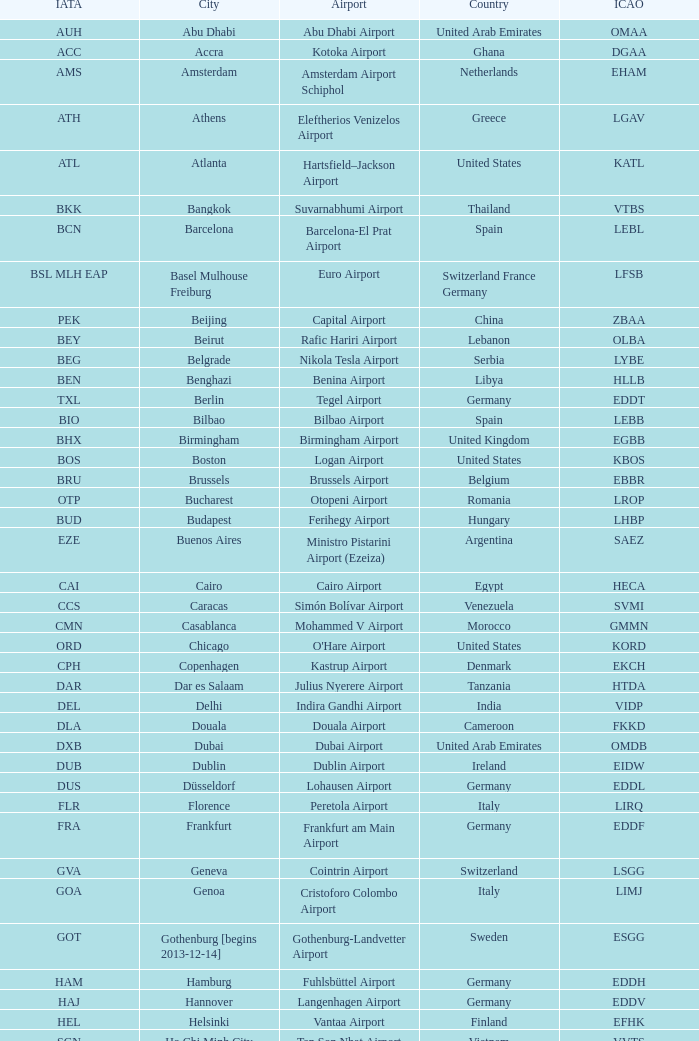Write the full table. {'header': ['IATA', 'City', 'Airport', 'Country', 'ICAO'], 'rows': [['AUH', 'Abu Dhabi', 'Abu Dhabi Airport', 'United Arab Emirates', 'OMAA'], ['ACC', 'Accra', 'Kotoka Airport', 'Ghana', 'DGAA'], ['AMS', 'Amsterdam', 'Amsterdam Airport Schiphol', 'Netherlands', 'EHAM'], ['ATH', 'Athens', 'Eleftherios Venizelos Airport', 'Greece', 'LGAV'], ['ATL', 'Atlanta', 'Hartsfield–Jackson Airport', 'United States', 'KATL'], ['BKK', 'Bangkok', 'Suvarnabhumi Airport', 'Thailand', 'VTBS'], ['BCN', 'Barcelona', 'Barcelona-El Prat Airport', 'Spain', 'LEBL'], ['BSL MLH EAP', 'Basel Mulhouse Freiburg', 'Euro Airport', 'Switzerland France Germany', 'LFSB'], ['PEK', 'Beijing', 'Capital Airport', 'China', 'ZBAA'], ['BEY', 'Beirut', 'Rafic Hariri Airport', 'Lebanon', 'OLBA'], ['BEG', 'Belgrade', 'Nikola Tesla Airport', 'Serbia', 'LYBE'], ['BEN', 'Benghazi', 'Benina Airport', 'Libya', 'HLLB'], ['TXL', 'Berlin', 'Tegel Airport', 'Germany', 'EDDT'], ['BIO', 'Bilbao', 'Bilbao Airport', 'Spain', 'LEBB'], ['BHX', 'Birmingham', 'Birmingham Airport', 'United Kingdom', 'EGBB'], ['BOS', 'Boston', 'Logan Airport', 'United States', 'KBOS'], ['BRU', 'Brussels', 'Brussels Airport', 'Belgium', 'EBBR'], ['OTP', 'Bucharest', 'Otopeni Airport', 'Romania', 'LROP'], ['BUD', 'Budapest', 'Ferihegy Airport', 'Hungary', 'LHBP'], ['EZE', 'Buenos Aires', 'Ministro Pistarini Airport (Ezeiza)', 'Argentina', 'SAEZ'], ['CAI', 'Cairo', 'Cairo Airport', 'Egypt', 'HECA'], ['CCS', 'Caracas', 'Simón Bolívar Airport', 'Venezuela', 'SVMI'], ['CMN', 'Casablanca', 'Mohammed V Airport', 'Morocco', 'GMMN'], ['ORD', 'Chicago', "O'Hare Airport", 'United States', 'KORD'], ['CPH', 'Copenhagen', 'Kastrup Airport', 'Denmark', 'EKCH'], ['DAR', 'Dar es Salaam', 'Julius Nyerere Airport', 'Tanzania', 'HTDA'], ['DEL', 'Delhi', 'Indira Gandhi Airport', 'India', 'VIDP'], ['DLA', 'Douala', 'Douala Airport', 'Cameroon', 'FKKD'], ['DXB', 'Dubai', 'Dubai Airport', 'United Arab Emirates', 'OMDB'], ['DUB', 'Dublin', 'Dublin Airport', 'Ireland', 'EIDW'], ['DUS', 'Düsseldorf', 'Lohausen Airport', 'Germany', 'EDDL'], ['FLR', 'Florence', 'Peretola Airport', 'Italy', 'LIRQ'], ['FRA', 'Frankfurt', 'Frankfurt am Main Airport', 'Germany', 'EDDF'], ['GVA', 'Geneva', 'Cointrin Airport', 'Switzerland', 'LSGG'], ['GOA', 'Genoa', 'Cristoforo Colombo Airport', 'Italy', 'LIMJ'], ['GOT', 'Gothenburg [begins 2013-12-14]', 'Gothenburg-Landvetter Airport', 'Sweden', 'ESGG'], ['HAM', 'Hamburg', 'Fuhlsbüttel Airport', 'Germany', 'EDDH'], ['HAJ', 'Hannover', 'Langenhagen Airport', 'Germany', 'EDDV'], ['HEL', 'Helsinki', 'Vantaa Airport', 'Finland', 'EFHK'], ['SGN', 'Ho Chi Minh City', 'Tan Son Nhat Airport', 'Vietnam', 'VVTS'], ['HKG', 'Hong Kong', 'Chek Lap Kok Airport', 'Hong Kong', 'VHHH'], ['IST', 'Istanbul', 'Atatürk Airport', 'Turkey', 'LTBA'], ['CGK', 'Jakarta', 'Soekarno–Hatta Airport', 'Indonesia', 'WIII'], ['JED', 'Jeddah', 'King Abdulaziz Airport', 'Saudi Arabia', 'OEJN'], ['JNB', 'Johannesburg', 'OR Tambo Airport', 'South Africa', 'FAJS'], ['KHI', 'Karachi', 'Jinnah Airport', 'Pakistan', 'OPKC'], ['KBP', 'Kiev', 'Boryspil International Airport', 'Ukraine', 'UKBB'], ['LOS', 'Lagos', 'Murtala Muhammed Airport', 'Nigeria', 'DNMM'], ['LBV', 'Libreville', "Leon M'ba Airport", 'Gabon', 'FOOL'], ['LIS', 'Lisbon', 'Portela Airport', 'Portugal', 'LPPT'], ['LCY', 'London', 'City Airport', 'United Kingdom', 'EGLC'], ['LGW', 'London [begins 2013-12-14]', 'Gatwick Airport', 'United Kingdom', 'EGKK'], ['LHR', 'London', 'Heathrow Airport', 'United Kingdom', 'EGLL'], ['LAX', 'Los Angeles', 'Los Angeles International Airport', 'United States', 'KLAX'], ['LUG', 'Lugano', 'Agno Airport', 'Switzerland', 'LSZA'], ['LUX', 'Luxembourg City', 'Findel Airport', 'Luxembourg', 'ELLX'], ['LYS', 'Lyon', 'Saint-Exupéry Airport', 'France', 'LFLL'], ['MAD', 'Madrid', 'Madrid-Barajas Airport', 'Spain', 'LEMD'], ['SSG', 'Malabo', 'Saint Isabel Airport', 'Equatorial Guinea', 'FGSL'], ['AGP', 'Malaga', 'Málaga-Costa del Sol Airport', 'Spain', 'LEMG'], ['MAN', 'Manchester', 'Ringway Airport', 'United Kingdom', 'EGCC'], ['MNL', 'Manila', 'Ninoy Aquino Airport', 'Philippines', 'RPLL'], ['RAK', 'Marrakech [begins 2013-11-01]', 'Menara Airport', 'Morocco', 'GMMX'], ['MIA', 'Miami', 'Miami Airport', 'United States', 'KMIA'], ['MXP', 'Milan', 'Malpensa Airport', 'Italy', 'LIMC'], ['MSP', 'Minneapolis', 'Minneapolis Airport', 'United States', 'KMSP'], ['YUL', 'Montreal', 'Pierre Elliott Trudeau Airport', 'Canada', 'CYUL'], ['DME', 'Moscow', 'Domodedovo Airport', 'Russia', 'UUDD'], ['BOM', 'Mumbai', 'Chhatrapati Shivaji Airport', 'India', 'VABB'], ['MUC', 'Munich', 'Franz Josef Strauss Airport', 'Germany', 'EDDM'], ['MCT', 'Muscat', 'Seeb Airport', 'Oman', 'OOMS'], ['NBO', 'Nairobi', 'Jomo Kenyatta Airport', 'Kenya', 'HKJK'], ['EWR', 'Newark', 'Liberty Airport', 'United States', 'KEWR'], ['JFK', 'New York City', 'John F Kennedy Airport', 'United States', 'KJFK'], ['NCE', 'Nice', "Côte d'Azur Airport", 'France', 'LFMN'], ['NUE', 'Nuremberg', 'Nuremberg Airport', 'Germany', 'EDDN'], ['OSL', 'Oslo', 'Gardermoen Airport', 'Norway', 'ENGM'], ['PMI', 'Palma de Mallorca', 'Palma de Mallorca Airport', 'Spain', 'LFPA'], ['CDG', 'Paris', 'Charles de Gaulle Airport', 'France', 'LFPG'], ['OPO', 'Porto', 'Francisco de Sa Carneiro Airport', 'Portugal', 'LPPR'], ['PRG', 'Prague', 'Ruzyně Airport', 'Czech Republic', 'LKPR'], ['RIX', 'Riga', 'Riga Airport', 'Latvia', 'EVRA'], ['GIG', 'Rio de Janeiro [resumes 2014-7-14]', 'Galeão Airport', 'Brazil', 'SBGL'], ['RUH', 'Riyadh', 'King Khalid Airport', 'Saudi Arabia', 'OERK'], ['FCO', 'Rome', 'Leonardo da Vinci Airport', 'Italy', 'LIRF'], ['LED', 'Saint Petersburg', 'Pulkovo Airport', 'Russia', 'ULLI'], ['SFO', 'San Francisco', 'San Francisco Airport', 'United States', 'KSFO'], ['SCL', 'Santiago', 'Comodoro Arturo Benitez Airport', 'Chile', 'SCEL'], ['GRU', 'São Paulo', 'Guarulhos Airport', 'Brazil', 'SBGR'], ['SJJ', 'Sarajevo', 'Butmir Airport', 'Bosnia and Herzegovina', 'LQSA'], ['SEA', 'Seattle', 'Sea-Tac Airport', 'United States', 'KSEA'], ['PVG', 'Shanghai', 'Pudong Airport', 'China', 'ZSPD'], ['SIN', 'Singapore', 'Changi Airport', 'Singapore', 'WSSS'], ['SKP', 'Skopje', 'Alexander the Great Airport', 'Republic of Macedonia', 'LWSK'], ['SOF', 'Sofia', 'Vrazhdebna Airport', 'Bulgaria', 'LBSF'], ['ARN', 'Stockholm', 'Arlanda Airport', 'Sweden', 'ESSA'], ['STR', 'Stuttgart', 'Echterdingen Airport', 'Germany', 'EDDS'], ['TPE', 'Taipei', 'Taoyuan Airport', 'Taiwan', 'RCTP'], ['IKA', 'Tehran', 'Imam Khomeini Airport', 'Iran', 'OIIE'], ['TLV', 'Tel Aviv', 'Ben Gurion Airport', 'Israel', 'LLBG'], ['SKG', 'Thessaloniki', 'Macedonia Airport', 'Greece', 'LGTS'], ['TIA', 'Tirana', 'Nënë Tereza Airport', 'Albania', 'LATI'], ['NRT', 'Tokyo', 'Narita Airport', 'Japan', 'RJAA'], ['YYZ', 'Toronto', 'Pearson Airport', 'Canada', 'CYYZ'], ['TIP', 'Tripoli', 'Tripoli Airport', 'Libya', 'HLLT'], ['TUN', 'Tunis', 'Carthage Airport', 'Tunisia', 'DTTA'], ['TRN', 'Turin', 'Sandro Pertini Airport', 'Italy', 'LIMF'], ['VLC', 'Valencia', 'Valencia Airport', 'Spain', 'LEVC'], ['VCE', 'Venice', 'Marco Polo Airport', 'Italy', 'LIPZ'], ['VIE', 'Vienna', 'Schwechat Airport', 'Austria', 'LOWW'], ['WAW', 'Warsaw', 'Frederic Chopin Airport', 'Poland', 'EPWA'], ['IAD', 'Washington DC', 'Dulles Airport', 'United States', 'KIAD'], ['NSI', 'Yaounde', 'Yaounde Nsimalen Airport', 'Cameroon', 'FKYS'], ['EVN', 'Yerevan', 'Zvartnots Airport', 'Armenia', 'UDYZ'], ['ZRH', 'Zurich', 'Zurich Airport', 'Switzerland', 'LSZH']]} Which city has the IATA SSG? Malabo. 